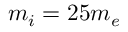<formula> <loc_0><loc_0><loc_500><loc_500>m _ { i } = 2 5 m _ { e }</formula> 